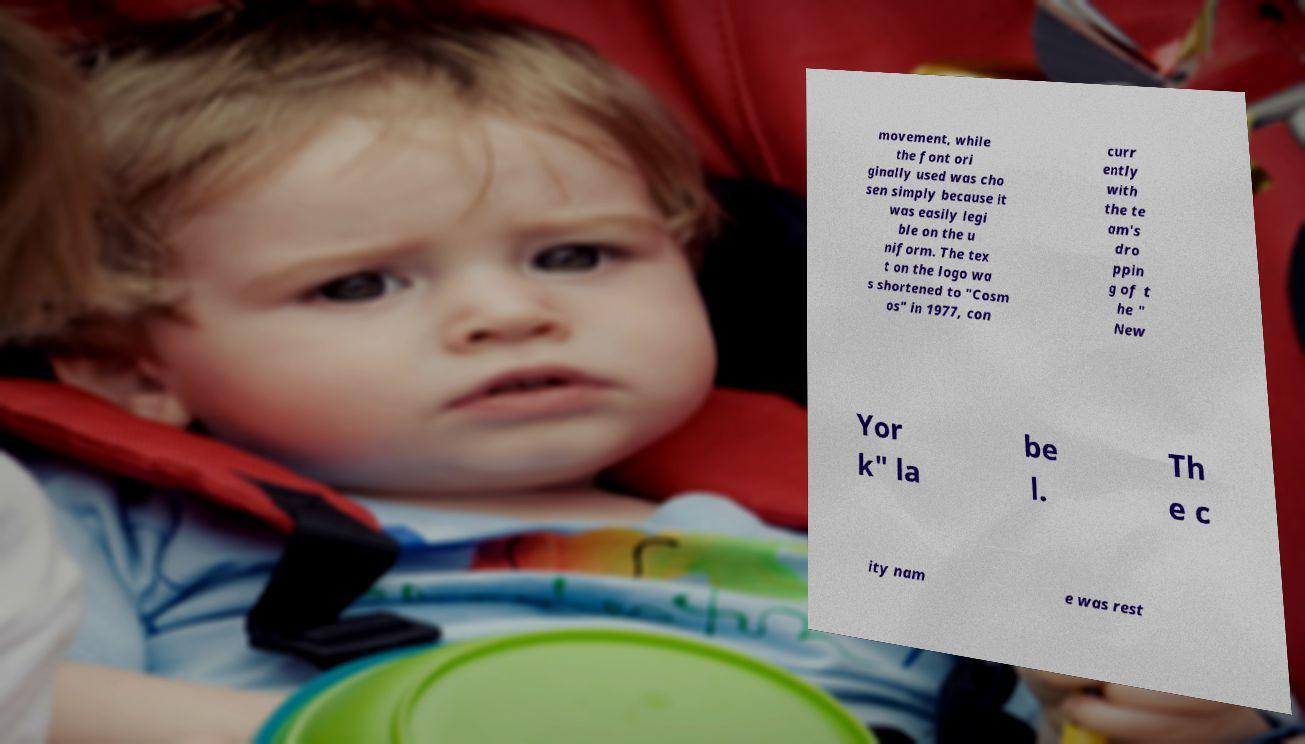Could you extract and type out the text from this image? movement, while the font ori ginally used was cho sen simply because it was easily legi ble on the u niform. The tex t on the logo wa s shortened to "Cosm os" in 1977, con curr ently with the te am's dro ppin g of t he " New Yor k" la be l. Th e c ity nam e was rest 